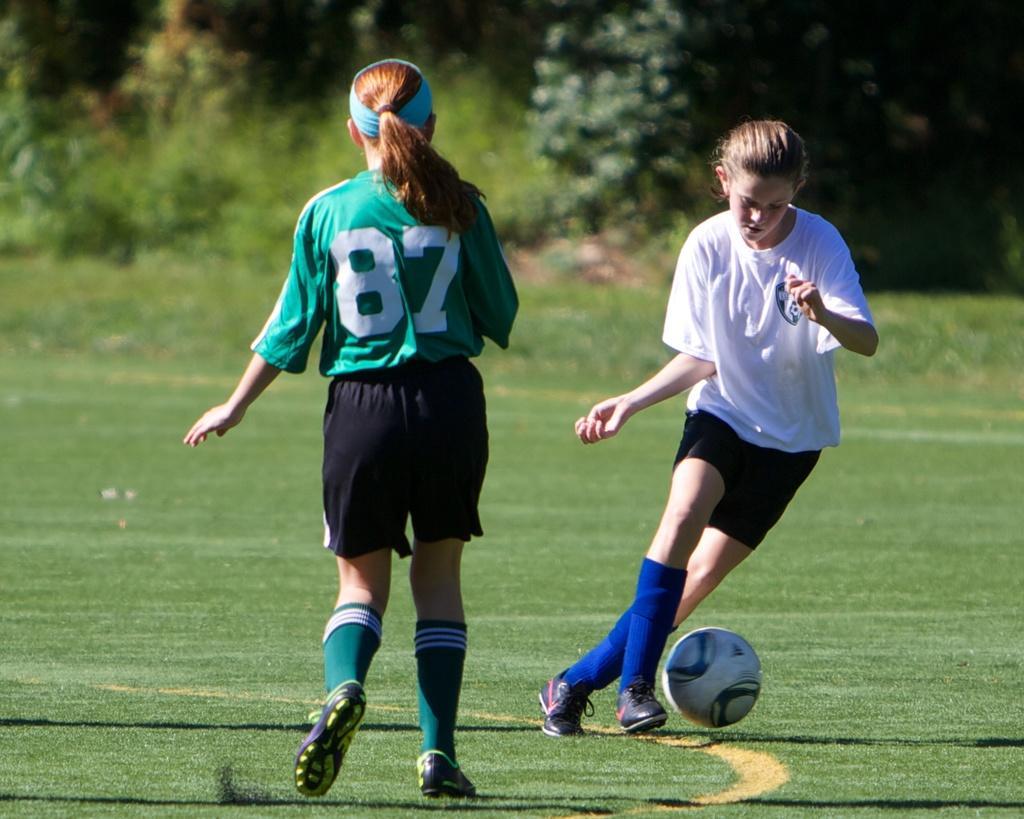How would you summarize this image in a sentence or two? In this image I can see two people are wearing different color dresses. I can see the ball, trees and the grass. 